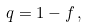Convert formula to latex. <formula><loc_0><loc_0><loc_500><loc_500>q = 1 - f \, ,</formula> 